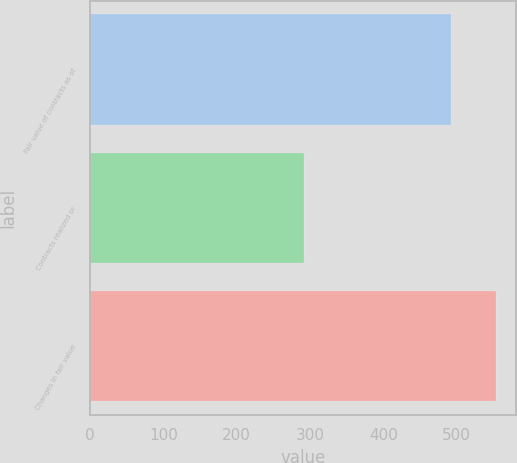Convert chart to OTSL. <chart><loc_0><loc_0><loc_500><loc_500><bar_chart><fcel>Fair value of contracts as of<fcel>Contracts realized or<fcel>Changes in fair value<nl><fcel>492<fcel>292<fcel>554<nl></chart> 